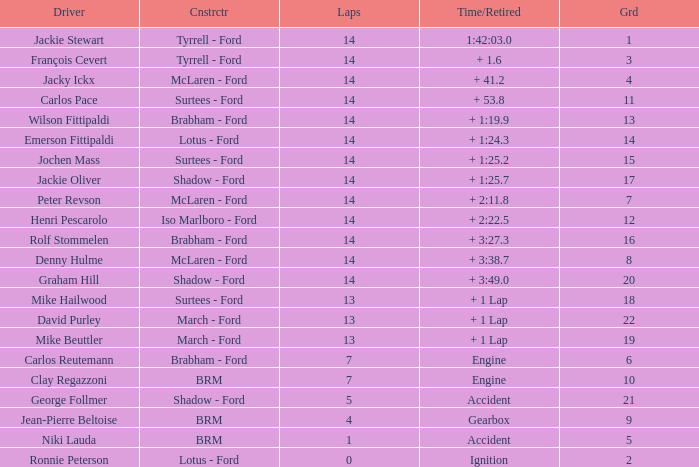What is the low lap total for a grid larger than 16 and has a Time/Retired of + 3:27.3? None. 